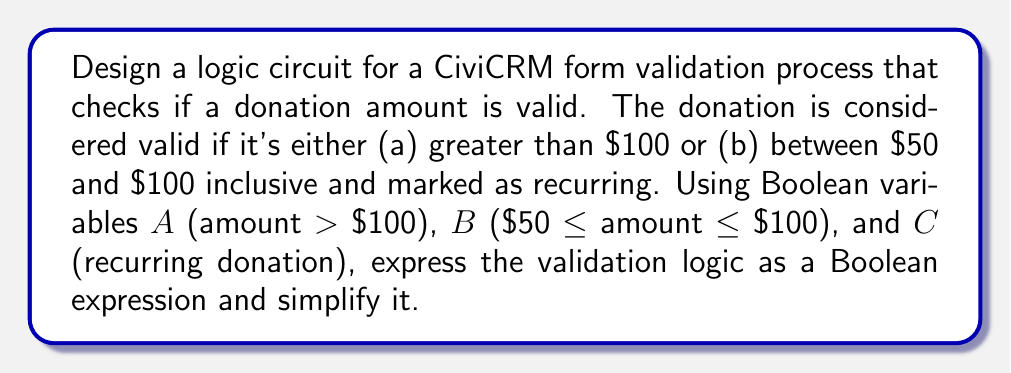Give your solution to this math problem. Let's approach this step-by-step:

1) First, let's define our Boolean variables:
   A: amount > $100
   B: $50 ≤ amount ≤ $100
   C: recurring donation

2) The donation is valid if:
   - It's greater than $100 (A is true), OR
   - It's between $50 and $100 inclusive (B is true) AND it's recurring (C is true)

3) We can express this logic as a Boolean expression:
   $$ F = A + (B \cdot C) $$

4) This expression is already in its simplest form, as it uses the minimum number of operations to represent the given logic.

5) To implement this in a logic circuit, we would need:
   - An OR gate for the final output
   - An AND gate to combine B and C

6) The circuit would look like this:

[asy]
import geometry;

pair A = (0,40), B = (0,20), C = (0,0);
pair AND = (60,10), OR = (120,25);
pair OUT = (180,25);

draw(A--OR);
draw(B--AND);
draw(C--AND);
draw(AND--OR);
draw(OR--OUT);

label("A", A, W);
label("B", B, W);
label("C", C, W);
label("AND", AND, E);
label("OR", OR, E);
label("F", OUT, E);

draw(circle(AND,10));
draw(circle(OR,10));

label("&", AND, fontsize(8));
label("≥1", OR, fontsize(8));
[/asy]

This circuit directly implements the Boolean expression $F = A + (B \cdot C)$.
Answer: $$ F = A + (B \cdot C) $$ 